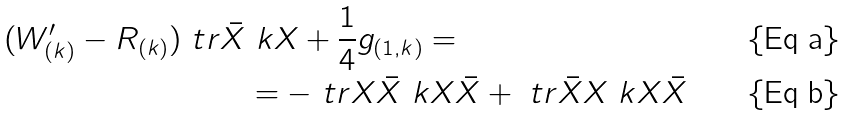<formula> <loc_0><loc_0><loc_500><loc_500>( W ^ { \prime } _ { ( k ) } - R _ { ( k ) } ) \ t r \bar { X } & \ k X + \frac { 1 } { 4 } g _ { ( 1 , k ) } = \\ & = - \ t r X \bar { X } \ k X \bar { X } + \ t r \bar { X } X \ k X \bar { X }</formula> 